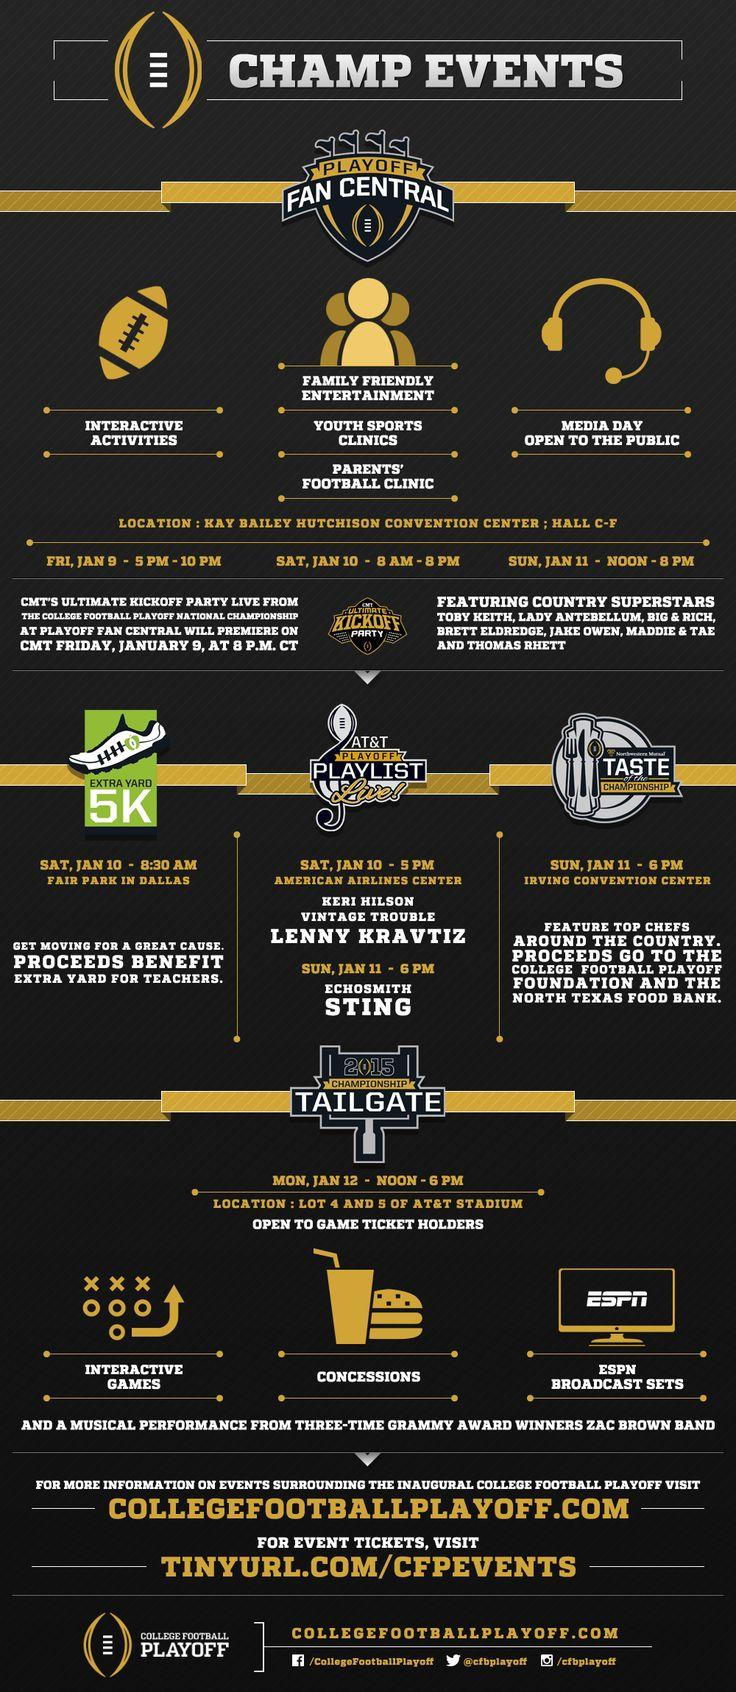Point out several critical features in this image. On Saturday, January 10th at 5:00 PM, the American Airlines Center will host AT&T Playoff Playlist Live!, an event showcasing the latest in technology and entertainment. The Media dat is open to the public from sunrise to sunset on Sunday, January 11th, from noon to 8:00 pm. The computer screen above the ESPN broadcast sets displays the word 'ESPN.' The extra yard 5k will be held at Fair Park in Dallas. The interactive activities are scheduled to take place on Friday, January 9, from 5:00 PM to 10:00 PM. 